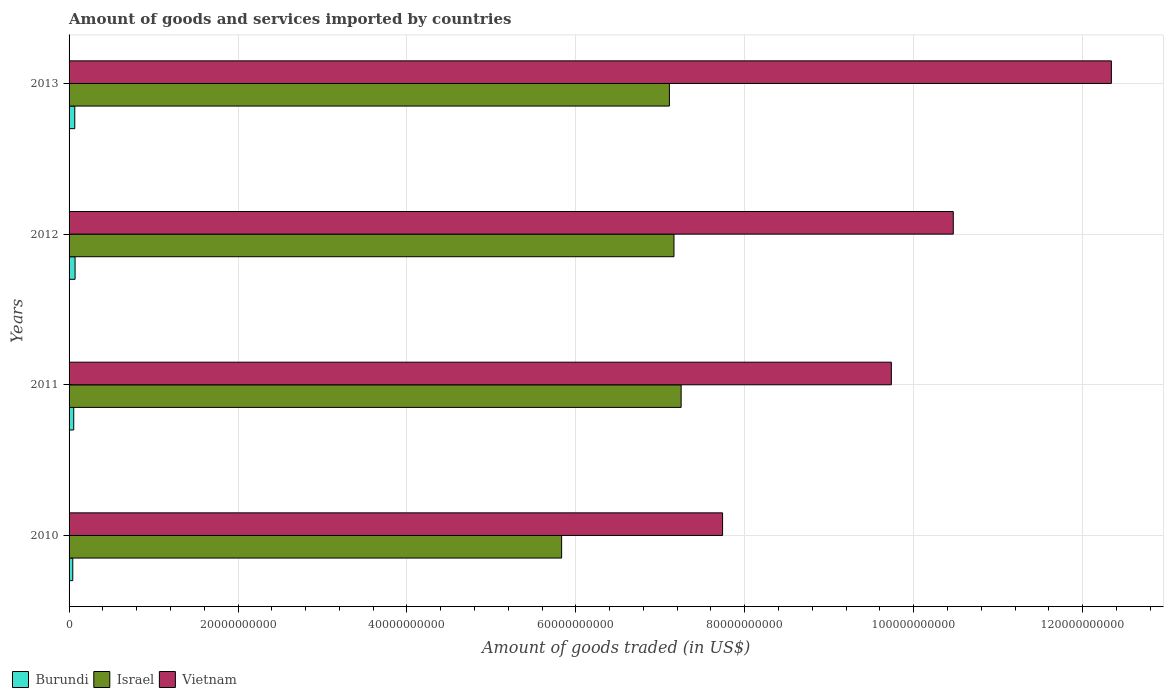How many different coloured bars are there?
Your answer should be compact. 3. Are the number of bars per tick equal to the number of legend labels?
Give a very brief answer. Yes. How many bars are there on the 3rd tick from the top?
Offer a terse response. 3. How many bars are there on the 4th tick from the bottom?
Provide a succinct answer. 3. In how many cases, is the number of bars for a given year not equal to the number of legend labels?
Your response must be concise. 0. What is the total amount of goods and services imported in Israel in 2012?
Your answer should be compact. 7.16e+1. Across all years, what is the maximum total amount of goods and services imported in Vietnam?
Ensure brevity in your answer.  1.23e+11. Across all years, what is the minimum total amount of goods and services imported in Burundi?
Provide a succinct answer. 4.38e+08. What is the total total amount of goods and services imported in Vietnam in the graph?
Your answer should be compact. 4.03e+11. What is the difference between the total amount of goods and services imported in Burundi in 2010 and that in 2012?
Your answer should be compact. -2.73e+08. What is the difference between the total amount of goods and services imported in Burundi in 2013 and the total amount of goods and services imported in Israel in 2012?
Your answer should be very brief. -7.09e+1. What is the average total amount of goods and services imported in Vietnam per year?
Your response must be concise. 1.01e+11. In the year 2011, what is the difference between the total amount of goods and services imported in Burundi and total amount of goods and services imported in Vietnam?
Ensure brevity in your answer.  -9.68e+1. In how many years, is the total amount of goods and services imported in Burundi greater than 112000000000 US$?
Make the answer very short. 0. What is the ratio of the total amount of goods and services imported in Israel in 2011 to that in 2012?
Make the answer very short. 1.01. Is the difference between the total amount of goods and services imported in Burundi in 2010 and 2011 greater than the difference between the total amount of goods and services imported in Vietnam in 2010 and 2011?
Your answer should be compact. Yes. What is the difference between the highest and the second highest total amount of goods and services imported in Israel?
Your response must be concise. 8.48e+08. What is the difference between the highest and the lowest total amount of goods and services imported in Israel?
Offer a terse response. 1.42e+1. What does the 1st bar from the bottom in 2011 represents?
Your response must be concise. Burundi. Is it the case that in every year, the sum of the total amount of goods and services imported in Israel and total amount of goods and services imported in Vietnam is greater than the total amount of goods and services imported in Burundi?
Your answer should be very brief. Yes. How many bars are there?
Provide a short and direct response. 12. Are the values on the major ticks of X-axis written in scientific E-notation?
Provide a short and direct response. No. Does the graph contain grids?
Offer a very short reply. Yes. How are the legend labels stacked?
Provide a short and direct response. Horizontal. What is the title of the graph?
Provide a short and direct response. Amount of goods and services imported by countries. What is the label or title of the X-axis?
Provide a short and direct response. Amount of goods traded (in US$). What is the Amount of goods traded (in US$) in Burundi in 2010?
Make the answer very short. 4.38e+08. What is the Amount of goods traded (in US$) in Israel in 2010?
Give a very brief answer. 5.83e+1. What is the Amount of goods traded (in US$) in Vietnam in 2010?
Offer a terse response. 7.74e+1. What is the Amount of goods traded (in US$) in Burundi in 2011?
Offer a very short reply. 5.52e+08. What is the Amount of goods traded (in US$) in Israel in 2011?
Ensure brevity in your answer.  7.25e+1. What is the Amount of goods traded (in US$) of Vietnam in 2011?
Give a very brief answer. 9.74e+1. What is the Amount of goods traded (in US$) in Burundi in 2012?
Your answer should be compact. 7.11e+08. What is the Amount of goods traded (in US$) in Israel in 2012?
Offer a very short reply. 7.16e+1. What is the Amount of goods traded (in US$) in Vietnam in 2012?
Your answer should be compact. 1.05e+11. What is the Amount of goods traded (in US$) of Burundi in 2013?
Your answer should be compact. 6.76e+08. What is the Amount of goods traded (in US$) of Israel in 2013?
Provide a short and direct response. 7.11e+1. What is the Amount of goods traded (in US$) of Vietnam in 2013?
Provide a succinct answer. 1.23e+11. Across all years, what is the maximum Amount of goods traded (in US$) in Burundi?
Ensure brevity in your answer.  7.11e+08. Across all years, what is the maximum Amount of goods traded (in US$) of Israel?
Keep it short and to the point. 7.25e+1. Across all years, what is the maximum Amount of goods traded (in US$) of Vietnam?
Give a very brief answer. 1.23e+11. Across all years, what is the minimum Amount of goods traded (in US$) of Burundi?
Make the answer very short. 4.38e+08. Across all years, what is the minimum Amount of goods traded (in US$) in Israel?
Provide a short and direct response. 5.83e+1. Across all years, what is the minimum Amount of goods traded (in US$) of Vietnam?
Ensure brevity in your answer.  7.74e+1. What is the total Amount of goods traded (in US$) of Burundi in the graph?
Give a very brief answer. 2.38e+09. What is the total Amount of goods traded (in US$) in Israel in the graph?
Provide a succinct answer. 2.73e+11. What is the total Amount of goods traded (in US$) of Vietnam in the graph?
Offer a very short reply. 4.03e+11. What is the difference between the Amount of goods traded (in US$) in Burundi in 2010 and that in 2011?
Keep it short and to the point. -1.14e+08. What is the difference between the Amount of goods traded (in US$) of Israel in 2010 and that in 2011?
Make the answer very short. -1.42e+1. What is the difference between the Amount of goods traded (in US$) of Vietnam in 2010 and that in 2011?
Offer a very short reply. -2.00e+1. What is the difference between the Amount of goods traded (in US$) in Burundi in 2010 and that in 2012?
Provide a short and direct response. -2.73e+08. What is the difference between the Amount of goods traded (in US$) of Israel in 2010 and that in 2012?
Your answer should be very brief. -1.33e+1. What is the difference between the Amount of goods traded (in US$) in Vietnam in 2010 and that in 2012?
Offer a very short reply. -2.73e+1. What is the difference between the Amount of goods traded (in US$) of Burundi in 2010 and that in 2013?
Your answer should be compact. -2.37e+08. What is the difference between the Amount of goods traded (in US$) of Israel in 2010 and that in 2013?
Provide a succinct answer. -1.28e+1. What is the difference between the Amount of goods traded (in US$) of Vietnam in 2010 and that in 2013?
Give a very brief answer. -4.60e+1. What is the difference between the Amount of goods traded (in US$) in Burundi in 2011 and that in 2012?
Make the answer very short. -1.59e+08. What is the difference between the Amount of goods traded (in US$) in Israel in 2011 and that in 2012?
Your answer should be compact. 8.48e+08. What is the difference between the Amount of goods traded (in US$) of Vietnam in 2011 and that in 2012?
Make the answer very short. -7.33e+09. What is the difference between the Amount of goods traded (in US$) in Burundi in 2011 and that in 2013?
Provide a short and direct response. -1.23e+08. What is the difference between the Amount of goods traded (in US$) in Israel in 2011 and that in 2013?
Keep it short and to the point. 1.39e+09. What is the difference between the Amount of goods traded (in US$) in Vietnam in 2011 and that in 2013?
Ensure brevity in your answer.  -2.60e+1. What is the difference between the Amount of goods traded (in US$) in Burundi in 2012 and that in 2013?
Your answer should be very brief. 3.55e+07. What is the difference between the Amount of goods traded (in US$) in Israel in 2012 and that in 2013?
Provide a short and direct response. 5.43e+08. What is the difference between the Amount of goods traded (in US$) in Vietnam in 2012 and that in 2013?
Your response must be concise. -1.87e+1. What is the difference between the Amount of goods traded (in US$) of Burundi in 2010 and the Amount of goods traded (in US$) of Israel in 2011?
Your response must be concise. -7.20e+1. What is the difference between the Amount of goods traded (in US$) in Burundi in 2010 and the Amount of goods traded (in US$) in Vietnam in 2011?
Provide a succinct answer. -9.69e+1. What is the difference between the Amount of goods traded (in US$) of Israel in 2010 and the Amount of goods traded (in US$) of Vietnam in 2011?
Give a very brief answer. -3.90e+1. What is the difference between the Amount of goods traded (in US$) in Burundi in 2010 and the Amount of goods traded (in US$) in Israel in 2012?
Provide a short and direct response. -7.12e+1. What is the difference between the Amount of goods traded (in US$) in Burundi in 2010 and the Amount of goods traded (in US$) in Vietnam in 2012?
Provide a short and direct response. -1.04e+11. What is the difference between the Amount of goods traded (in US$) of Israel in 2010 and the Amount of goods traded (in US$) of Vietnam in 2012?
Give a very brief answer. -4.64e+1. What is the difference between the Amount of goods traded (in US$) of Burundi in 2010 and the Amount of goods traded (in US$) of Israel in 2013?
Your answer should be very brief. -7.06e+1. What is the difference between the Amount of goods traded (in US$) of Burundi in 2010 and the Amount of goods traded (in US$) of Vietnam in 2013?
Give a very brief answer. -1.23e+11. What is the difference between the Amount of goods traded (in US$) in Israel in 2010 and the Amount of goods traded (in US$) in Vietnam in 2013?
Your answer should be compact. -6.51e+1. What is the difference between the Amount of goods traded (in US$) in Burundi in 2011 and the Amount of goods traded (in US$) in Israel in 2012?
Your response must be concise. -7.11e+1. What is the difference between the Amount of goods traded (in US$) of Burundi in 2011 and the Amount of goods traded (in US$) of Vietnam in 2012?
Keep it short and to the point. -1.04e+11. What is the difference between the Amount of goods traded (in US$) in Israel in 2011 and the Amount of goods traded (in US$) in Vietnam in 2012?
Offer a terse response. -3.22e+1. What is the difference between the Amount of goods traded (in US$) of Burundi in 2011 and the Amount of goods traded (in US$) of Israel in 2013?
Make the answer very short. -7.05e+1. What is the difference between the Amount of goods traded (in US$) of Burundi in 2011 and the Amount of goods traded (in US$) of Vietnam in 2013?
Make the answer very short. -1.23e+11. What is the difference between the Amount of goods traded (in US$) in Israel in 2011 and the Amount of goods traded (in US$) in Vietnam in 2013?
Provide a short and direct response. -5.09e+1. What is the difference between the Amount of goods traded (in US$) of Burundi in 2012 and the Amount of goods traded (in US$) of Israel in 2013?
Provide a succinct answer. -7.04e+1. What is the difference between the Amount of goods traded (in US$) of Burundi in 2012 and the Amount of goods traded (in US$) of Vietnam in 2013?
Your response must be concise. -1.23e+11. What is the difference between the Amount of goods traded (in US$) of Israel in 2012 and the Amount of goods traded (in US$) of Vietnam in 2013?
Give a very brief answer. -5.18e+1. What is the average Amount of goods traded (in US$) of Burundi per year?
Your response must be concise. 5.94e+08. What is the average Amount of goods traded (in US$) of Israel per year?
Give a very brief answer. 6.84e+1. What is the average Amount of goods traded (in US$) in Vietnam per year?
Your response must be concise. 1.01e+11. In the year 2010, what is the difference between the Amount of goods traded (in US$) in Burundi and Amount of goods traded (in US$) in Israel?
Your answer should be very brief. -5.79e+1. In the year 2010, what is the difference between the Amount of goods traded (in US$) in Burundi and Amount of goods traded (in US$) in Vietnam?
Offer a terse response. -7.69e+1. In the year 2010, what is the difference between the Amount of goods traded (in US$) in Israel and Amount of goods traded (in US$) in Vietnam?
Your response must be concise. -1.91e+1. In the year 2011, what is the difference between the Amount of goods traded (in US$) of Burundi and Amount of goods traded (in US$) of Israel?
Keep it short and to the point. -7.19e+1. In the year 2011, what is the difference between the Amount of goods traded (in US$) in Burundi and Amount of goods traded (in US$) in Vietnam?
Make the answer very short. -9.68e+1. In the year 2011, what is the difference between the Amount of goods traded (in US$) of Israel and Amount of goods traded (in US$) of Vietnam?
Provide a short and direct response. -2.49e+1. In the year 2012, what is the difference between the Amount of goods traded (in US$) of Burundi and Amount of goods traded (in US$) of Israel?
Offer a very short reply. -7.09e+1. In the year 2012, what is the difference between the Amount of goods traded (in US$) of Burundi and Amount of goods traded (in US$) of Vietnam?
Ensure brevity in your answer.  -1.04e+11. In the year 2012, what is the difference between the Amount of goods traded (in US$) of Israel and Amount of goods traded (in US$) of Vietnam?
Give a very brief answer. -3.31e+1. In the year 2013, what is the difference between the Amount of goods traded (in US$) in Burundi and Amount of goods traded (in US$) in Israel?
Your answer should be compact. -7.04e+1. In the year 2013, what is the difference between the Amount of goods traded (in US$) in Burundi and Amount of goods traded (in US$) in Vietnam?
Keep it short and to the point. -1.23e+11. In the year 2013, what is the difference between the Amount of goods traded (in US$) of Israel and Amount of goods traded (in US$) of Vietnam?
Keep it short and to the point. -5.23e+1. What is the ratio of the Amount of goods traded (in US$) in Burundi in 2010 to that in 2011?
Your answer should be very brief. 0.79. What is the ratio of the Amount of goods traded (in US$) of Israel in 2010 to that in 2011?
Ensure brevity in your answer.  0.8. What is the ratio of the Amount of goods traded (in US$) of Vietnam in 2010 to that in 2011?
Make the answer very short. 0.79. What is the ratio of the Amount of goods traded (in US$) in Burundi in 2010 to that in 2012?
Keep it short and to the point. 0.62. What is the ratio of the Amount of goods traded (in US$) of Israel in 2010 to that in 2012?
Your answer should be compact. 0.81. What is the ratio of the Amount of goods traded (in US$) in Vietnam in 2010 to that in 2012?
Provide a succinct answer. 0.74. What is the ratio of the Amount of goods traded (in US$) in Burundi in 2010 to that in 2013?
Give a very brief answer. 0.65. What is the ratio of the Amount of goods traded (in US$) in Israel in 2010 to that in 2013?
Your answer should be compact. 0.82. What is the ratio of the Amount of goods traded (in US$) of Vietnam in 2010 to that in 2013?
Your answer should be very brief. 0.63. What is the ratio of the Amount of goods traded (in US$) of Burundi in 2011 to that in 2012?
Give a very brief answer. 0.78. What is the ratio of the Amount of goods traded (in US$) in Israel in 2011 to that in 2012?
Ensure brevity in your answer.  1.01. What is the ratio of the Amount of goods traded (in US$) of Burundi in 2011 to that in 2013?
Your answer should be very brief. 0.82. What is the ratio of the Amount of goods traded (in US$) of Israel in 2011 to that in 2013?
Your response must be concise. 1.02. What is the ratio of the Amount of goods traded (in US$) of Vietnam in 2011 to that in 2013?
Make the answer very short. 0.79. What is the ratio of the Amount of goods traded (in US$) of Burundi in 2012 to that in 2013?
Provide a short and direct response. 1.05. What is the ratio of the Amount of goods traded (in US$) of Israel in 2012 to that in 2013?
Provide a succinct answer. 1.01. What is the ratio of the Amount of goods traded (in US$) of Vietnam in 2012 to that in 2013?
Your response must be concise. 0.85. What is the difference between the highest and the second highest Amount of goods traded (in US$) in Burundi?
Offer a terse response. 3.55e+07. What is the difference between the highest and the second highest Amount of goods traded (in US$) in Israel?
Your answer should be compact. 8.48e+08. What is the difference between the highest and the second highest Amount of goods traded (in US$) in Vietnam?
Provide a succinct answer. 1.87e+1. What is the difference between the highest and the lowest Amount of goods traded (in US$) of Burundi?
Ensure brevity in your answer.  2.73e+08. What is the difference between the highest and the lowest Amount of goods traded (in US$) of Israel?
Your response must be concise. 1.42e+1. What is the difference between the highest and the lowest Amount of goods traded (in US$) of Vietnam?
Provide a short and direct response. 4.60e+1. 